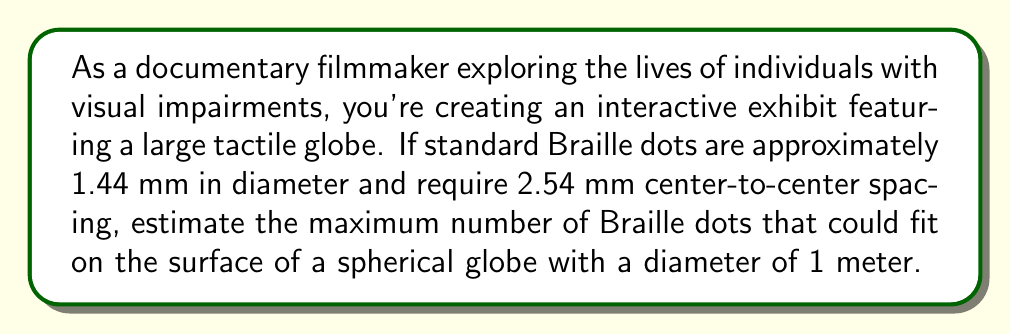What is the answer to this math problem? To solve this problem, we'll follow these steps:

1) First, calculate the surface area of the spherical globe:
   The surface area of a sphere is given by $A = 4\pi r^2$, where $r$ is the radius.
   $$A = 4\pi (0.5\text{ m})^2 = \pi \text{ m}^2 \approx 3.14159 \text{ m}^2$$

2) Convert the surface area to square millimeters:
   $$3.14159 \text{ m}^2 = 3,141,590 \text{ mm}^2$$

3) Calculate the area needed for each Braille dot, including spacing:
   The dots require 2.54 mm center-to-center spacing, which we can treat as a square.
   $$2.54 \text{ mm} \times 2.54 \text{ mm} = 6.4516 \text{ mm}^2$$

4) Estimate the number of dots by dividing the total surface area by the area needed for each dot:
   $$\frac{3,141,590 \text{ mm}^2}{6.4516 \text{ mm}^2} \approx 486,965$$

5) Round down to the nearest thousand to account for imperfect packing and potential curvature issues:
   $$486,965 \approx 486,000$$

Therefore, we estimate that approximately 486,000 Braille dots could fit on the surface of the globe.
Answer: Approximately 486,000 Braille dots 